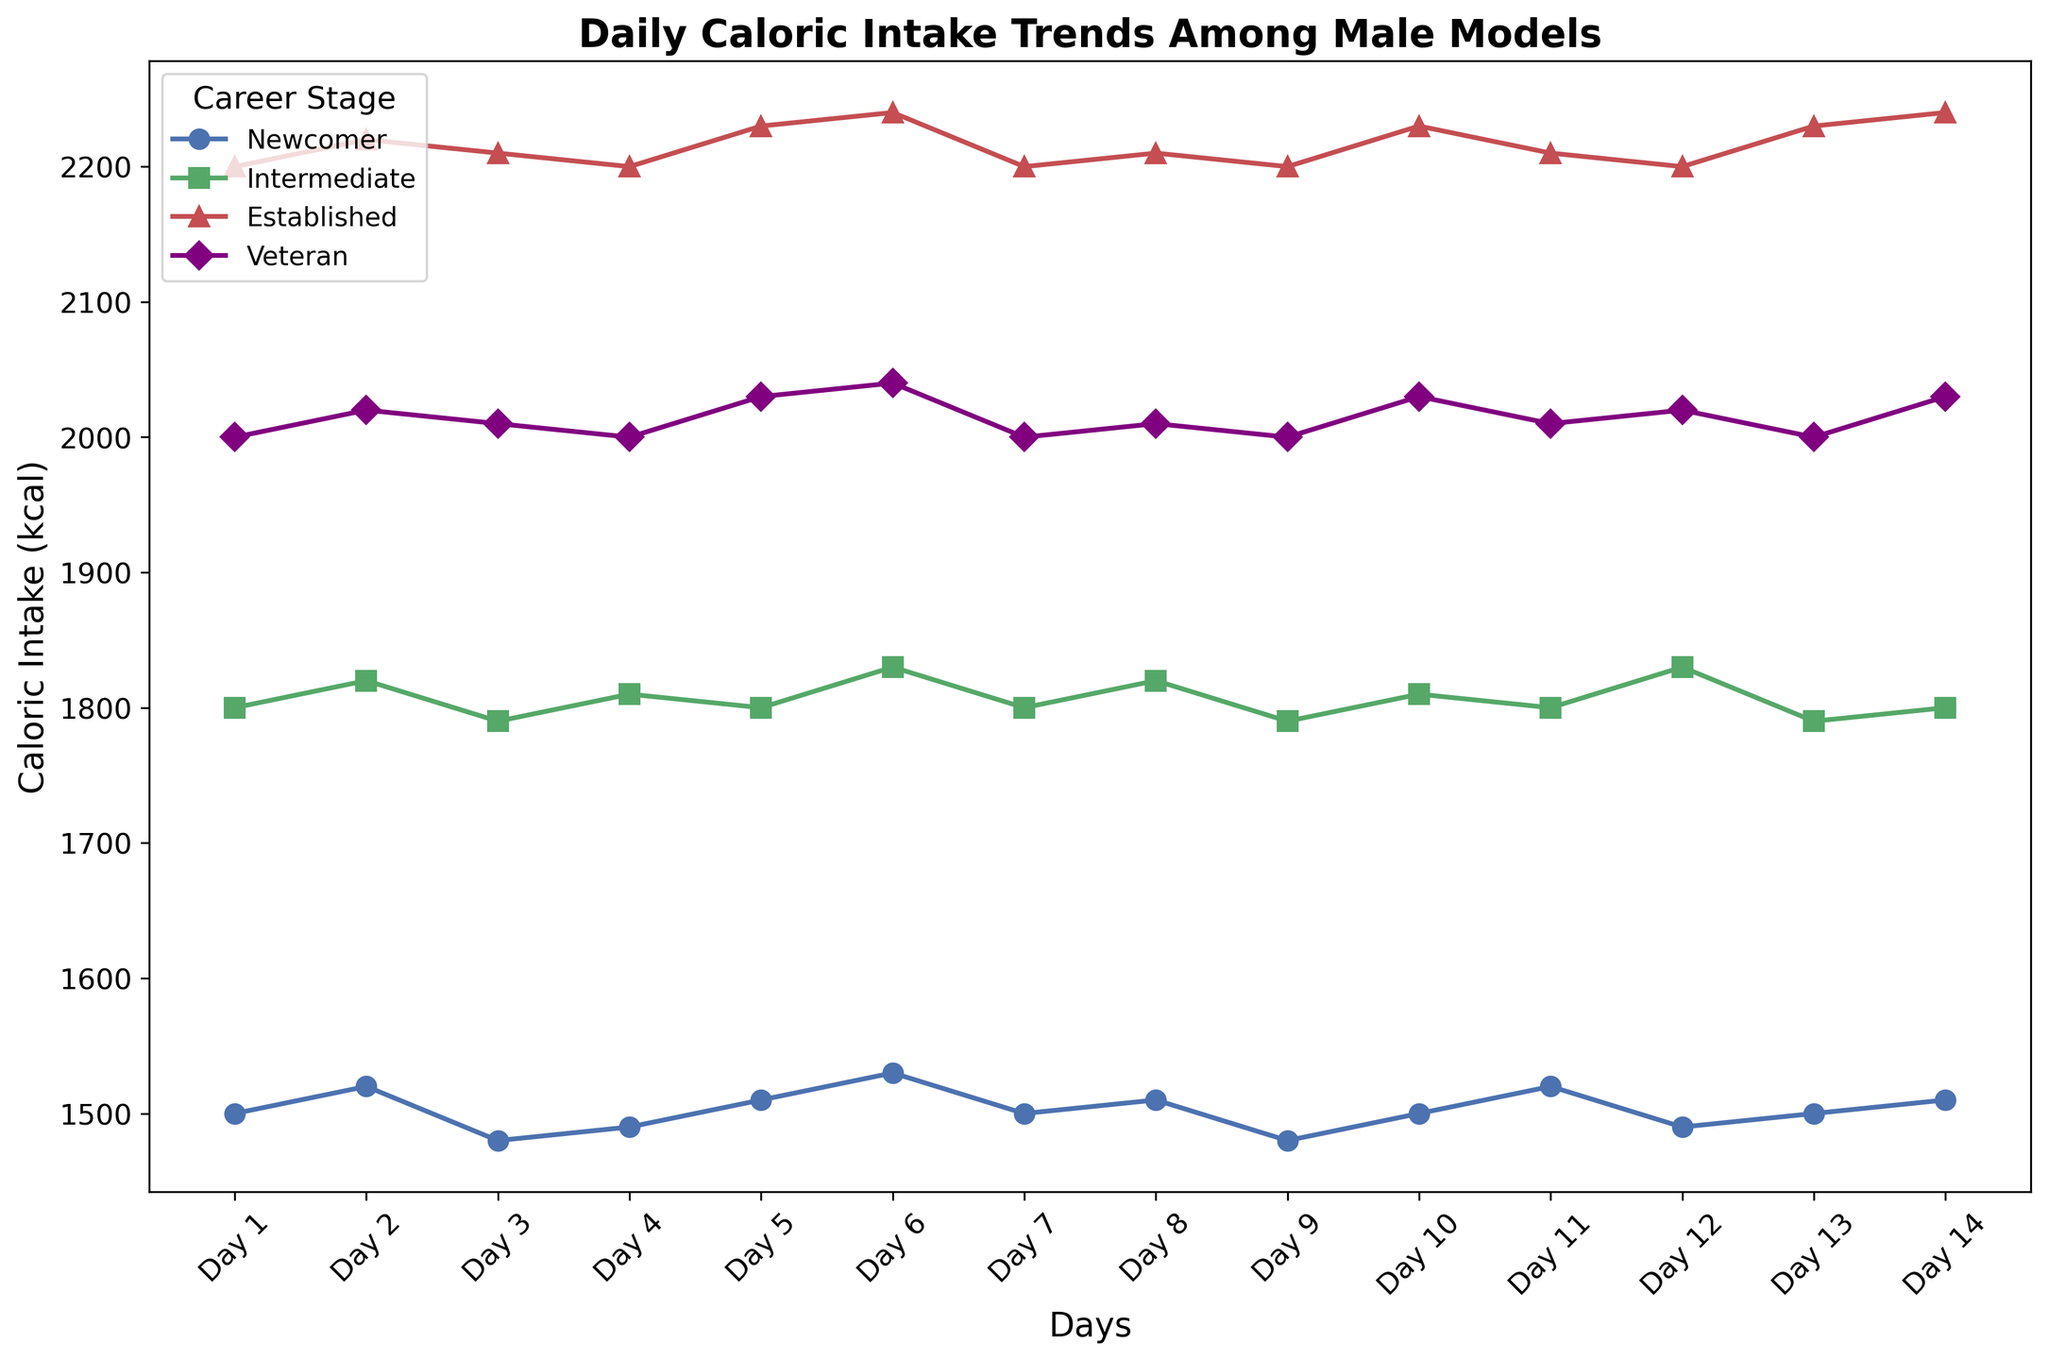What's the average daily caloric intake for a newcomer over the 14 days? To find the average, sum up the caloric intake values for a newcomer across the 14 days: (1500 + 1520 + 1480 + 1490 + 1510 + 1530 + 1500 + 1510 + 1480 + 1500 + 1520 + 1490 + 1500 + 1510) = 21040. Divide this sum by 14 to get the average: 21040 / 14 = 1502.86
Answer: 1502.86 kcal Which career stage shows the highest caloric intake on Day 5? By visually scanning the graph, the caloric intake values for Day 5 are noted for each career stage. The values are: Newcomer (1510), Intermediate (1800), Established (2230), and Veteran (2030). The highest value belongs to the Established stage with 2230 kcal.
Answer: Established Is there a career stage whose caloric intake remains constant over a three-day period? If so, which one? By examining the lines representing caloric intake, the Veteran career stage has a constant intake of 2000 kcal from Day 9 to Day 11.
Answer: Veteran What is the difference in caloric intake between an Intermediate and a Veteran on Day 7? Look at the values for Day 7: Intermediate is 1800 kcal and Veteran is 2000 kcal. The difference is calculated as 2000 - 1800 = 200 kcal.
Answer: 200 kcal Which career stage has the most fluctuating caloric intake trend over the 14 days? By visually assessing the variability in the lines, the Established and Veteran stages show the most fluctuations. To find the exact answer, compare the variances. The Established trend fluctuates from 2200 to 2240, while the Veteran trend fluctuates from 2000 to 2040. The one with higher fluctuations (variance) is the Established stage.
Answer: Established On which day do all career stages' caloric intakes overlap the least? By observing where the plotted lines diverge the most, one can determine that Day 5 shows the most divergence, with caloric intakes of Newcomer (1510), Intermediate (1800), Established (2230), and Veteran (2030).
Answer: Day 5 How many days do Newcomers have an intake above 1500 kcal? By checking the Newcomer values for each day, we find that the caloric intake exceeds 1500 on Day 2 (1520), Day 5 (1510), Day 6 (1530), Day 8 (1510), Day 10 (1520), Day 13 (1500 - counted as above 1500), and Day 14 (1510), making it 7 days.
Answer: 7 days What is the total caloric intake over 14 days for the Veteran stage? Add up the caloric intake values for the Veteran stage: (2000 + 2020 + 2010 + 2000 + 2030 + 2040 + 2000 + 2010 + 2000 + 2030 + 2010 + 2020 + 2000 + 2030) = 28120 kcal.
Answer: 28120 kcal 